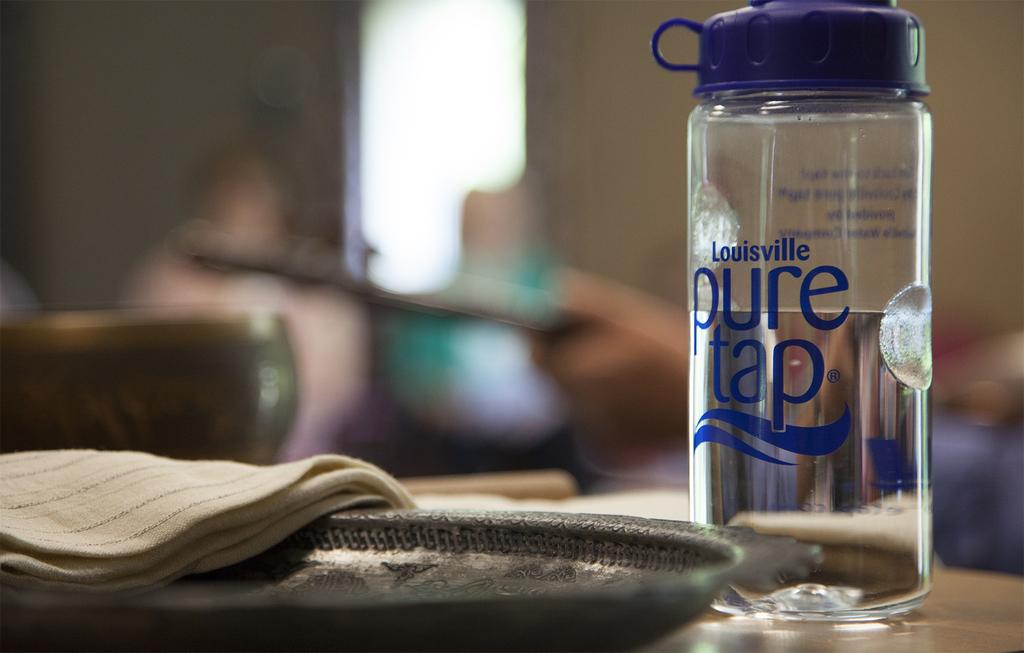What object can be seen on the floor in the image? There is a bottle on the floor in the image. What is inside the bottle? The bottle is filled with water. What is located next to the bottle? There is a plate next to the bottle. What is on the plate? There is a cloth on the plate. Can you see any boats in the harbor in the image? There is no harbor or boats present in the image. What insect might be crawling on the cloth in the image? There are no insects visible in the image. 